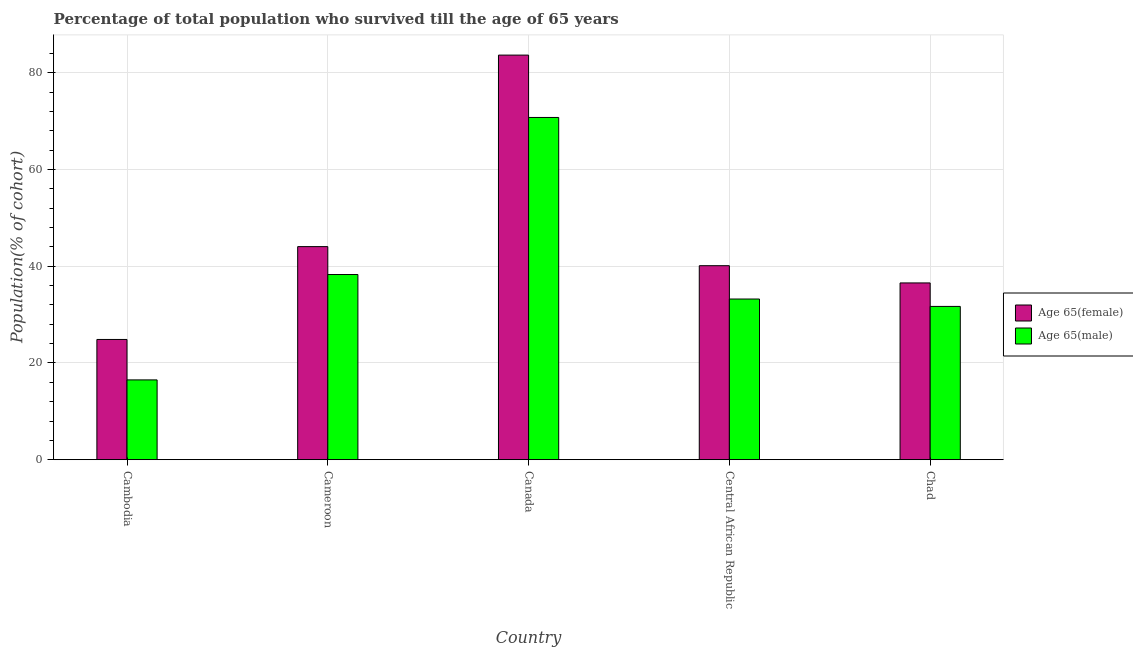How many groups of bars are there?
Make the answer very short. 5. How many bars are there on the 3rd tick from the right?
Offer a terse response. 2. What is the label of the 5th group of bars from the left?
Your answer should be very brief. Chad. In how many cases, is the number of bars for a given country not equal to the number of legend labels?
Offer a very short reply. 0. What is the percentage of female population who survived till age of 65 in Chad?
Ensure brevity in your answer.  36.55. Across all countries, what is the maximum percentage of female population who survived till age of 65?
Provide a succinct answer. 83.66. Across all countries, what is the minimum percentage of male population who survived till age of 65?
Provide a short and direct response. 16.5. In which country was the percentage of male population who survived till age of 65 minimum?
Make the answer very short. Cambodia. What is the total percentage of female population who survived till age of 65 in the graph?
Your answer should be compact. 229.26. What is the difference between the percentage of female population who survived till age of 65 in Cambodia and that in Cameroon?
Keep it short and to the point. -19.2. What is the difference between the percentage of female population who survived till age of 65 in Cambodia and the percentage of male population who survived till age of 65 in Cameroon?
Ensure brevity in your answer.  -13.43. What is the average percentage of male population who survived till age of 65 per country?
Offer a terse response. 38.1. What is the difference between the percentage of female population who survived till age of 65 and percentage of male population who survived till age of 65 in Cambodia?
Your answer should be very brief. 8.36. What is the ratio of the percentage of female population who survived till age of 65 in Cambodia to that in Chad?
Ensure brevity in your answer.  0.68. Is the percentage of male population who survived till age of 65 in Cameroon less than that in Canada?
Offer a very short reply. Yes. What is the difference between the highest and the second highest percentage of male population who survived till age of 65?
Provide a short and direct response. 32.48. What is the difference between the highest and the lowest percentage of female population who survived till age of 65?
Offer a very short reply. 58.8. What does the 2nd bar from the left in Canada represents?
Your answer should be very brief. Age 65(male). What does the 1st bar from the right in Cambodia represents?
Provide a succinct answer. Age 65(male). How many bars are there?
Give a very brief answer. 10. Are all the bars in the graph horizontal?
Provide a short and direct response. No. Are the values on the major ticks of Y-axis written in scientific E-notation?
Make the answer very short. No. How many legend labels are there?
Keep it short and to the point. 2. How are the legend labels stacked?
Make the answer very short. Vertical. What is the title of the graph?
Make the answer very short. Percentage of total population who survived till the age of 65 years. What is the label or title of the Y-axis?
Offer a terse response. Population(% of cohort). What is the Population(% of cohort) in Age 65(female) in Cambodia?
Your response must be concise. 24.86. What is the Population(% of cohort) of Age 65(male) in Cambodia?
Provide a succinct answer. 16.5. What is the Population(% of cohort) in Age 65(female) in Cameroon?
Make the answer very short. 44.06. What is the Population(% of cohort) in Age 65(male) in Cameroon?
Your response must be concise. 38.29. What is the Population(% of cohort) in Age 65(female) in Canada?
Ensure brevity in your answer.  83.66. What is the Population(% of cohort) in Age 65(male) in Canada?
Your response must be concise. 70.77. What is the Population(% of cohort) of Age 65(female) in Central African Republic?
Provide a short and direct response. 40.12. What is the Population(% of cohort) of Age 65(male) in Central African Republic?
Keep it short and to the point. 33.22. What is the Population(% of cohort) of Age 65(female) in Chad?
Your answer should be compact. 36.55. What is the Population(% of cohort) in Age 65(male) in Chad?
Make the answer very short. 31.7. Across all countries, what is the maximum Population(% of cohort) of Age 65(female)?
Your answer should be very brief. 83.66. Across all countries, what is the maximum Population(% of cohort) of Age 65(male)?
Keep it short and to the point. 70.77. Across all countries, what is the minimum Population(% of cohort) of Age 65(female)?
Your answer should be very brief. 24.86. Across all countries, what is the minimum Population(% of cohort) of Age 65(male)?
Make the answer very short. 16.5. What is the total Population(% of cohort) in Age 65(female) in the graph?
Keep it short and to the point. 229.26. What is the total Population(% of cohort) of Age 65(male) in the graph?
Provide a short and direct response. 190.48. What is the difference between the Population(% of cohort) of Age 65(female) in Cambodia and that in Cameroon?
Make the answer very short. -19.2. What is the difference between the Population(% of cohort) in Age 65(male) in Cambodia and that in Cameroon?
Provide a short and direct response. -21.79. What is the difference between the Population(% of cohort) in Age 65(female) in Cambodia and that in Canada?
Ensure brevity in your answer.  -58.8. What is the difference between the Population(% of cohort) in Age 65(male) in Cambodia and that in Canada?
Provide a succinct answer. -54.27. What is the difference between the Population(% of cohort) of Age 65(female) in Cambodia and that in Central African Republic?
Your answer should be compact. -15.25. What is the difference between the Population(% of cohort) in Age 65(male) in Cambodia and that in Central African Republic?
Give a very brief answer. -16.72. What is the difference between the Population(% of cohort) in Age 65(female) in Cambodia and that in Chad?
Your answer should be compact. -11.69. What is the difference between the Population(% of cohort) in Age 65(male) in Cambodia and that in Chad?
Your answer should be very brief. -15.2. What is the difference between the Population(% of cohort) in Age 65(female) in Cameroon and that in Canada?
Keep it short and to the point. -39.6. What is the difference between the Population(% of cohort) of Age 65(male) in Cameroon and that in Canada?
Offer a very short reply. -32.48. What is the difference between the Population(% of cohort) in Age 65(female) in Cameroon and that in Central African Republic?
Give a very brief answer. 3.95. What is the difference between the Population(% of cohort) of Age 65(male) in Cameroon and that in Central African Republic?
Give a very brief answer. 5.07. What is the difference between the Population(% of cohort) of Age 65(female) in Cameroon and that in Chad?
Make the answer very short. 7.51. What is the difference between the Population(% of cohort) of Age 65(male) in Cameroon and that in Chad?
Ensure brevity in your answer.  6.59. What is the difference between the Population(% of cohort) of Age 65(female) in Canada and that in Central African Republic?
Ensure brevity in your answer.  43.55. What is the difference between the Population(% of cohort) of Age 65(male) in Canada and that in Central African Republic?
Your answer should be compact. 37.54. What is the difference between the Population(% of cohort) of Age 65(female) in Canada and that in Chad?
Your answer should be compact. 47.11. What is the difference between the Population(% of cohort) in Age 65(male) in Canada and that in Chad?
Provide a short and direct response. 39.07. What is the difference between the Population(% of cohort) of Age 65(female) in Central African Republic and that in Chad?
Provide a succinct answer. 3.56. What is the difference between the Population(% of cohort) in Age 65(male) in Central African Republic and that in Chad?
Your answer should be very brief. 1.53. What is the difference between the Population(% of cohort) in Age 65(female) in Cambodia and the Population(% of cohort) in Age 65(male) in Cameroon?
Keep it short and to the point. -13.43. What is the difference between the Population(% of cohort) of Age 65(female) in Cambodia and the Population(% of cohort) of Age 65(male) in Canada?
Your response must be concise. -45.91. What is the difference between the Population(% of cohort) of Age 65(female) in Cambodia and the Population(% of cohort) of Age 65(male) in Central African Republic?
Provide a short and direct response. -8.36. What is the difference between the Population(% of cohort) in Age 65(female) in Cambodia and the Population(% of cohort) in Age 65(male) in Chad?
Offer a very short reply. -6.83. What is the difference between the Population(% of cohort) in Age 65(female) in Cameroon and the Population(% of cohort) in Age 65(male) in Canada?
Your response must be concise. -26.71. What is the difference between the Population(% of cohort) in Age 65(female) in Cameroon and the Population(% of cohort) in Age 65(male) in Central African Republic?
Give a very brief answer. 10.84. What is the difference between the Population(% of cohort) of Age 65(female) in Cameroon and the Population(% of cohort) of Age 65(male) in Chad?
Give a very brief answer. 12.37. What is the difference between the Population(% of cohort) in Age 65(female) in Canada and the Population(% of cohort) in Age 65(male) in Central African Republic?
Provide a succinct answer. 50.44. What is the difference between the Population(% of cohort) of Age 65(female) in Canada and the Population(% of cohort) of Age 65(male) in Chad?
Offer a terse response. 51.97. What is the difference between the Population(% of cohort) in Age 65(female) in Central African Republic and the Population(% of cohort) in Age 65(male) in Chad?
Offer a terse response. 8.42. What is the average Population(% of cohort) in Age 65(female) per country?
Make the answer very short. 45.85. What is the average Population(% of cohort) in Age 65(male) per country?
Your response must be concise. 38.1. What is the difference between the Population(% of cohort) of Age 65(female) and Population(% of cohort) of Age 65(male) in Cambodia?
Offer a very short reply. 8.36. What is the difference between the Population(% of cohort) of Age 65(female) and Population(% of cohort) of Age 65(male) in Cameroon?
Ensure brevity in your answer.  5.77. What is the difference between the Population(% of cohort) in Age 65(female) and Population(% of cohort) in Age 65(male) in Canada?
Ensure brevity in your answer.  12.89. What is the difference between the Population(% of cohort) of Age 65(female) and Population(% of cohort) of Age 65(male) in Central African Republic?
Offer a terse response. 6.89. What is the difference between the Population(% of cohort) in Age 65(female) and Population(% of cohort) in Age 65(male) in Chad?
Provide a succinct answer. 4.86. What is the ratio of the Population(% of cohort) in Age 65(female) in Cambodia to that in Cameroon?
Offer a terse response. 0.56. What is the ratio of the Population(% of cohort) in Age 65(male) in Cambodia to that in Cameroon?
Ensure brevity in your answer.  0.43. What is the ratio of the Population(% of cohort) in Age 65(female) in Cambodia to that in Canada?
Your answer should be very brief. 0.3. What is the ratio of the Population(% of cohort) in Age 65(male) in Cambodia to that in Canada?
Your response must be concise. 0.23. What is the ratio of the Population(% of cohort) in Age 65(female) in Cambodia to that in Central African Republic?
Your answer should be very brief. 0.62. What is the ratio of the Population(% of cohort) of Age 65(male) in Cambodia to that in Central African Republic?
Your answer should be very brief. 0.5. What is the ratio of the Population(% of cohort) of Age 65(female) in Cambodia to that in Chad?
Offer a terse response. 0.68. What is the ratio of the Population(% of cohort) in Age 65(male) in Cambodia to that in Chad?
Offer a very short reply. 0.52. What is the ratio of the Population(% of cohort) of Age 65(female) in Cameroon to that in Canada?
Your response must be concise. 0.53. What is the ratio of the Population(% of cohort) of Age 65(male) in Cameroon to that in Canada?
Keep it short and to the point. 0.54. What is the ratio of the Population(% of cohort) in Age 65(female) in Cameroon to that in Central African Republic?
Ensure brevity in your answer.  1.1. What is the ratio of the Population(% of cohort) of Age 65(male) in Cameroon to that in Central African Republic?
Make the answer very short. 1.15. What is the ratio of the Population(% of cohort) of Age 65(female) in Cameroon to that in Chad?
Offer a very short reply. 1.21. What is the ratio of the Population(% of cohort) of Age 65(male) in Cameroon to that in Chad?
Your answer should be very brief. 1.21. What is the ratio of the Population(% of cohort) of Age 65(female) in Canada to that in Central African Republic?
Offer a very short reply. 2.09. What is the ratio of the Population(% of cohort) of Age 65(male) in Canada to that in Central African Republic?
Offer a very short reply. 2.13. What is the ratio of the Population(% of cohort) in Age 65(female) in Canada to that in Chad?
Provide a succinct answer. 2.29. What is the ratio of the Population(% of cohort) in Age 65(male) in Canada to that in Chad?
Your answer should be compact. 2.23. What is the ratio of the Population(% of cohort) in Age 65(female) in Central African Republic to that in Chad?
Make the answer very short. 1.1. What is the ratio of the Population(% of cohort) of Age 65(male) in Central African Republic to that in Chad?
Your answer should be compact. 1.05. What is the difference between the highest and the second highest Population(% of cohort) in Age 65(female)?
Keep it short and to the point. 39.6. What is the difference between the highest and the second highest Population(% of cohort) in Age 65(male)?
Keep it short and to the point. 32.48. What is the difference between the highest and the lowest Population(% of cohort) in Age 65(female)?
Offer a terse response. 58.8. What is the difference between the highest and the lowest Population(% of cohort) of Age 65(male)?
Offer a terse response. 54.27. 